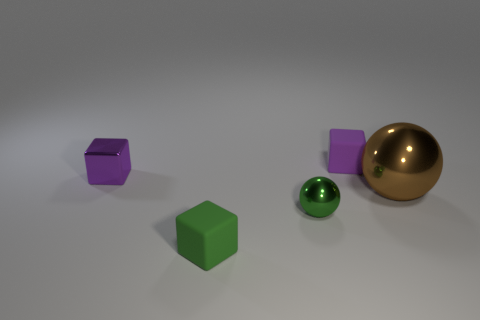How many tiny balls are there?
Keep it short and to the point. 1. Are the ball that is left of the brown ball and the brown thing made of the same material?
Offer a terse response. Yes. There is a thing that is on the right side of the small green matte thing and behind the brown metallic ball; what is its material?
Offer a terse response. Rubber. There is a block that is the same color as the small shiny sphere; what size is it?
Your response must be concise. Small. What material is the small green thing that is to the left of the tiny green object that is right of the tiny green rubber object?
Give a very brief answer. Rubber. How big is the metal ball that is on the left side of the purple object that is on the right side of the tiny purple thing left of the green cube?
Your response must be concise. Small. What number of brown objects are the same material as the green ball?
Offer a very short reply. 1. What is the color of the tiny rubber cube that is left of the small metal thing that is in front of the large shiny sphere?
Give a very brief answer. Green. What number of objects are either small matte blocks or green spheres to the right of the tiny purple shiny thing?
Your answer should be compact. 3. Are there any rubber things of the same color as the small metallic block?
Keep it short and to the point. Yes. 